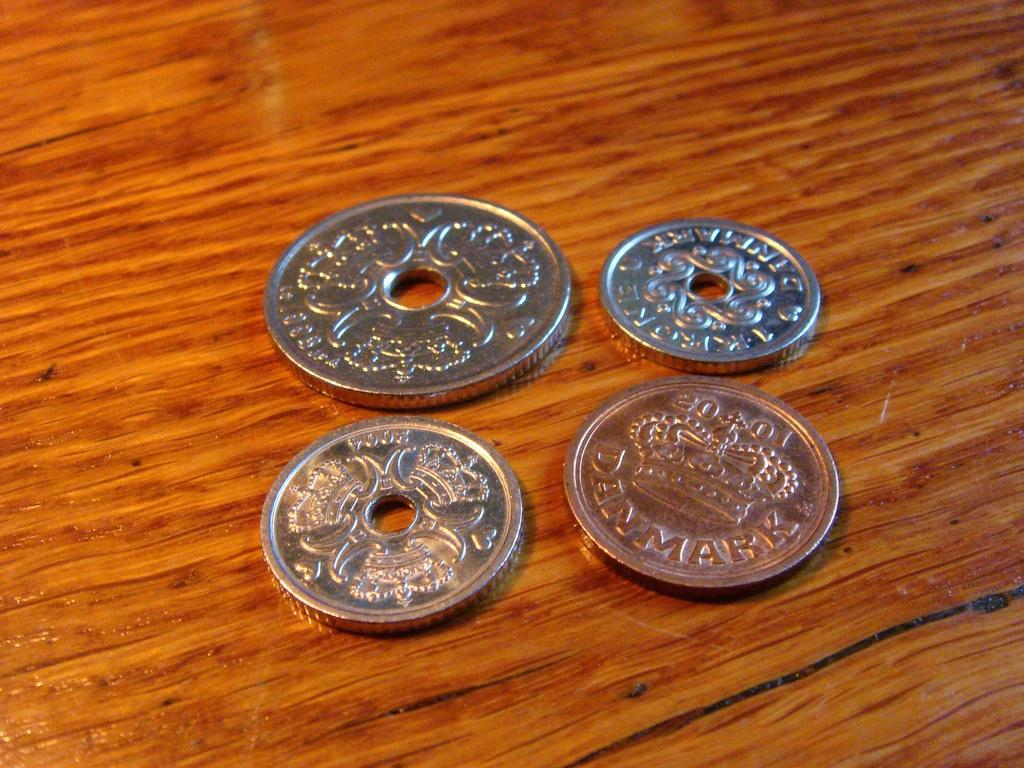<image>
Give a short and clear explanation of the subsequent image. Four coins showing Denmark stamps are on the table. 